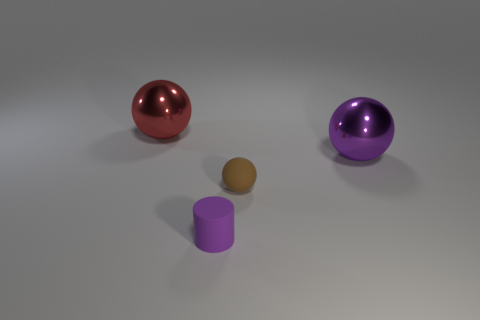There is a big red thing that is the same shape as the small brown object; what is its material?
Your response must be concise. Metal. Do the red shiny ball and the purple shiny thing that is in front of the large red sphere have the same size?
Ensure brevity in your answer.  Yes. What is the shape of the object that is behind the purple matte object and in front of the big purple metallic object?
Your response must be concise. Sphere. How many tiny things are purple cylinders or red shiny objects?
Offer a very short reply. 1. Is the number of cylinders that are to the left of the tiny brown matte object the same as the number of large purple metallic balls that are left of the purple rubber cylinder?
Provide a succinct answer. No. How many other objects are the same color as the small cylinder?
Give a very brief answer. 1. Are there the same number of purple cylinders that are in front of the purple cylinder and tiny purple matte objects?
Offer a terse response. No. Is the red object the same size as the brown rubber thing?
Make the answer very short. No. What is the material of the sphere that is both behind the small brown rubber object and to the right of the purple rubber cylinder?
Your answer should be very brief. Metal. How many other metal things are the same shape as the big purple thing?
Offer a very short reply. 1. 